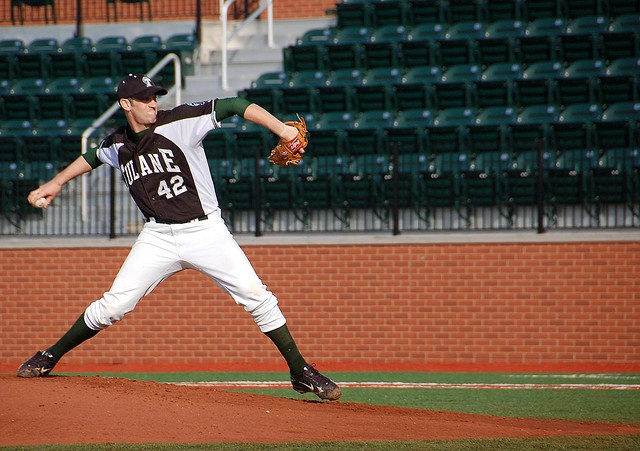Describe the objects in this image and their specific colors. I can see chair in brown, black, teal, darkgray, and darkblue tones, people in brown, white, black, and darkgray tones, chair in brown, black, teal, purple, and darkblue tones, chair in brown, black, teal, purple, and darkblue tones, and chair in brown, black, teal, darkblue, and gray tones in this image. 